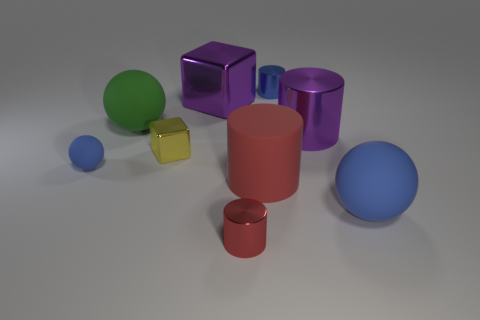What number of big purple metal objects are both left of the small red metal cylinder and on the right side of the big red matte cylinder?
Give a very brief answer. 0. Is the number of metal things behind the large green matte sphere less than the number of tiny red things?
Keep it short and to the point. No. There is a blue object that is the same size as the blue cylinder; what is its shape?
Make the answer very short. Sphere. What number of other things are there of the same color as the large block?
Your answer should be very brief. 1. Is the size of the purple metallic cylinder the same as the blue cylinder?
Give a very brief answer. No. How many objects are either green cylinders or shiny things behind the large purple cube?
Your response must be concise. 1. Are there fewer spheres that are to the left of the large red rubber object than rubber cylinders that are left of the purple cube?
Provide a short and direct response. No. How many other objects are there of the same material as the yellow cube?
Your answer should be compact. 4. Is the color of the small shiny cylinder in front of the blue metallic cylinder the same as the rubber cylinder?
Your answer should be very brief. Yes. Are there any green spheres in front of the metallic cylinder that is in front of the large blue thing?
Provide a succinct answer. No. 